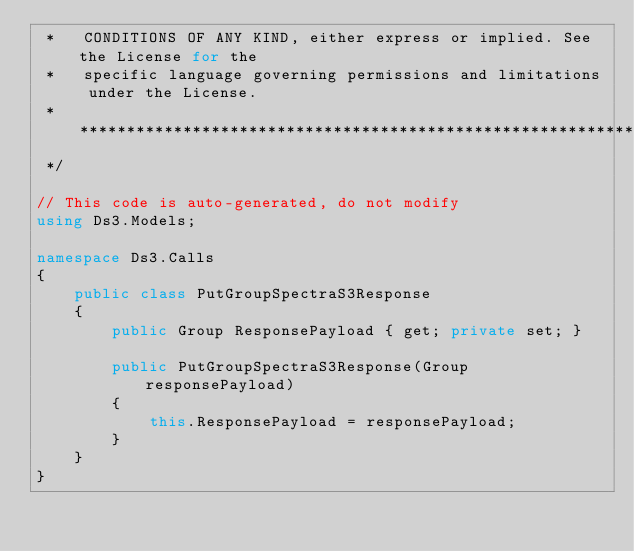<code> <loc_0><loc_0><loc_500><loc_500><_C#_> *   CONDITIONS OF ANY KIND, either express or implied. See the License for the
 *   specific language governing permissions and limitations under the License.
 * ****************************************************************************
 */

// This code is auto-generated, do not modify
using Ds3.Models;

namespace Ds3.Calls
{
    public class PutGroupSpectraS3Response
    {
        public Group ResponsePayload { get; private set; }

        public PutGroupSpectraS3Response(Group responsePayload)
        {
            this.ResponsePayload = responsePayload;
        }
    }
}
</code> 